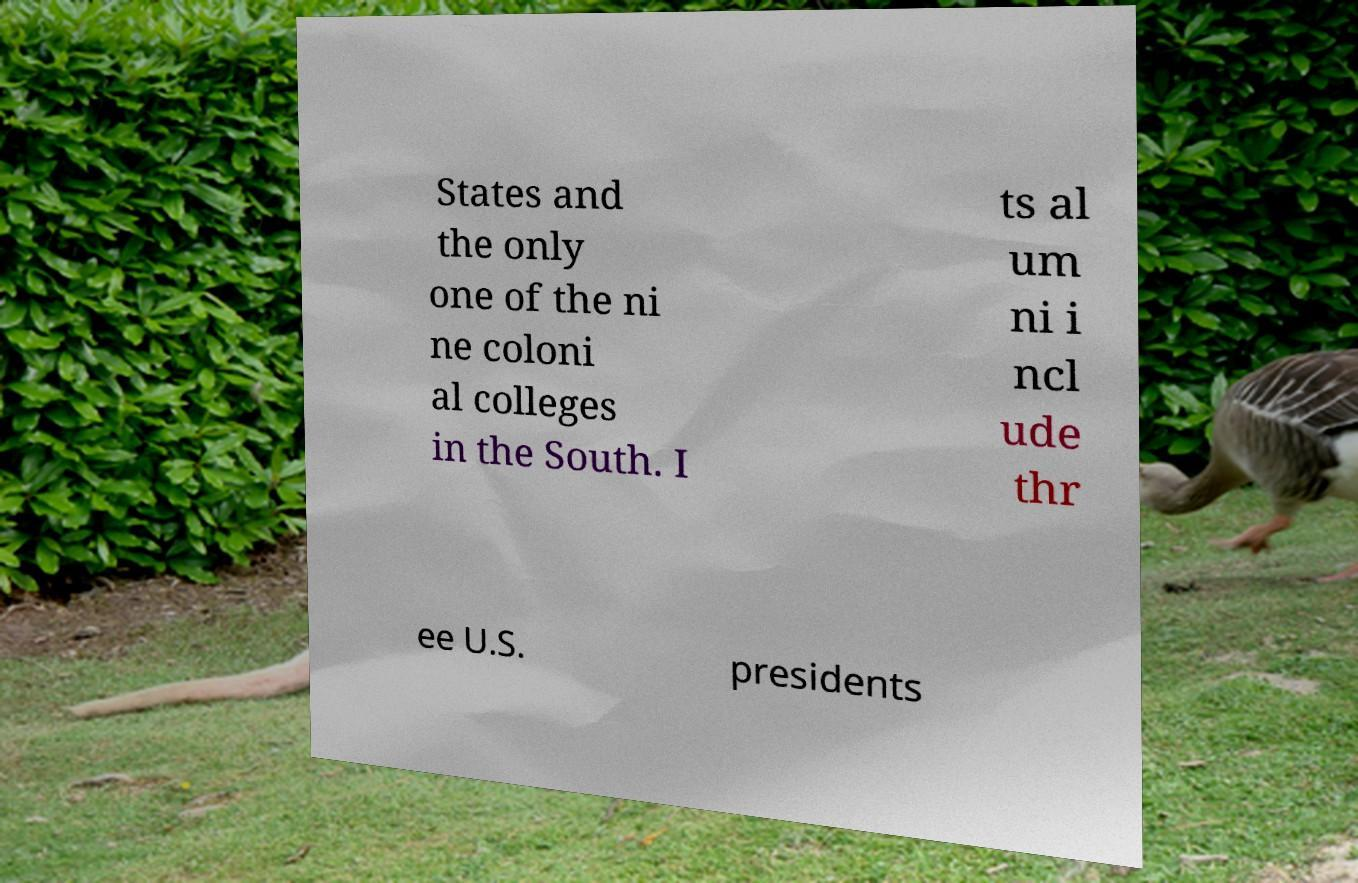I need the written content from this picture converted into text. Can you do that? States and the only one of the ni ne coloni al colleges in the South. I ts al um ni i ncl ude thr ee U.S. presidents 